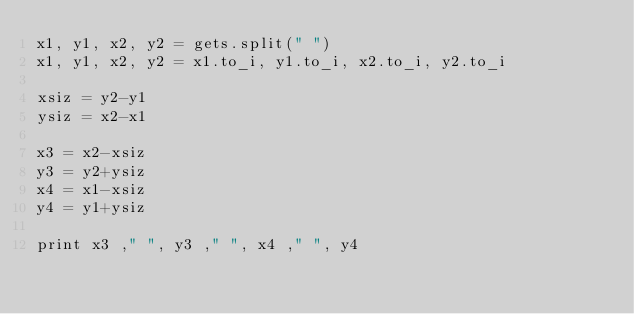<code> <loc_0><loc_0><loc_500><loc_500><_Ruby_>x1, y1, x2, y2 = gets.split(" ")
x1, y1, x2, y2 = x1.to_i, y1.to_i, x2.to_i, y2.to_i

xsiz = y2-y1
ysiz = x2-x1

x3 = x2-xsiz
y3 = y2+ysiz
x4 = x1-xsiz
y4 = y1+ysiz

print x3 ," ", y3 ," ", x4 ," ", y4</code> 